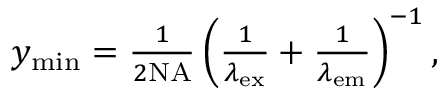Convert formula to latex. <formula><loc_0><loc_0><loc_500><loc_500>\begin{array} { r } { y _ { \min } = \frac { 1 } { 2 N A } \left ( \frac { 1 } { \lambda _ { e x } } + \frac { 1 } { \lambda _ { e m } } \right ) ^ { - 1 } , } \end{array}</formula> 